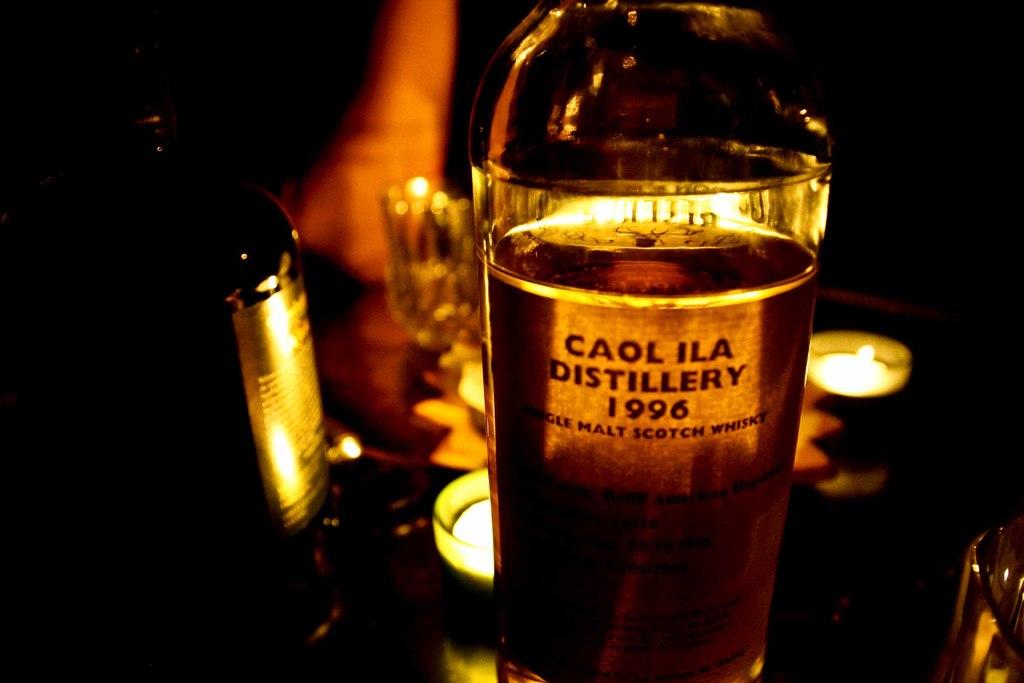What year is the bottle of whiskey from?
Offer a terse response. 1996. What distillery is this from?
Make the answer very short. Caol ila. 